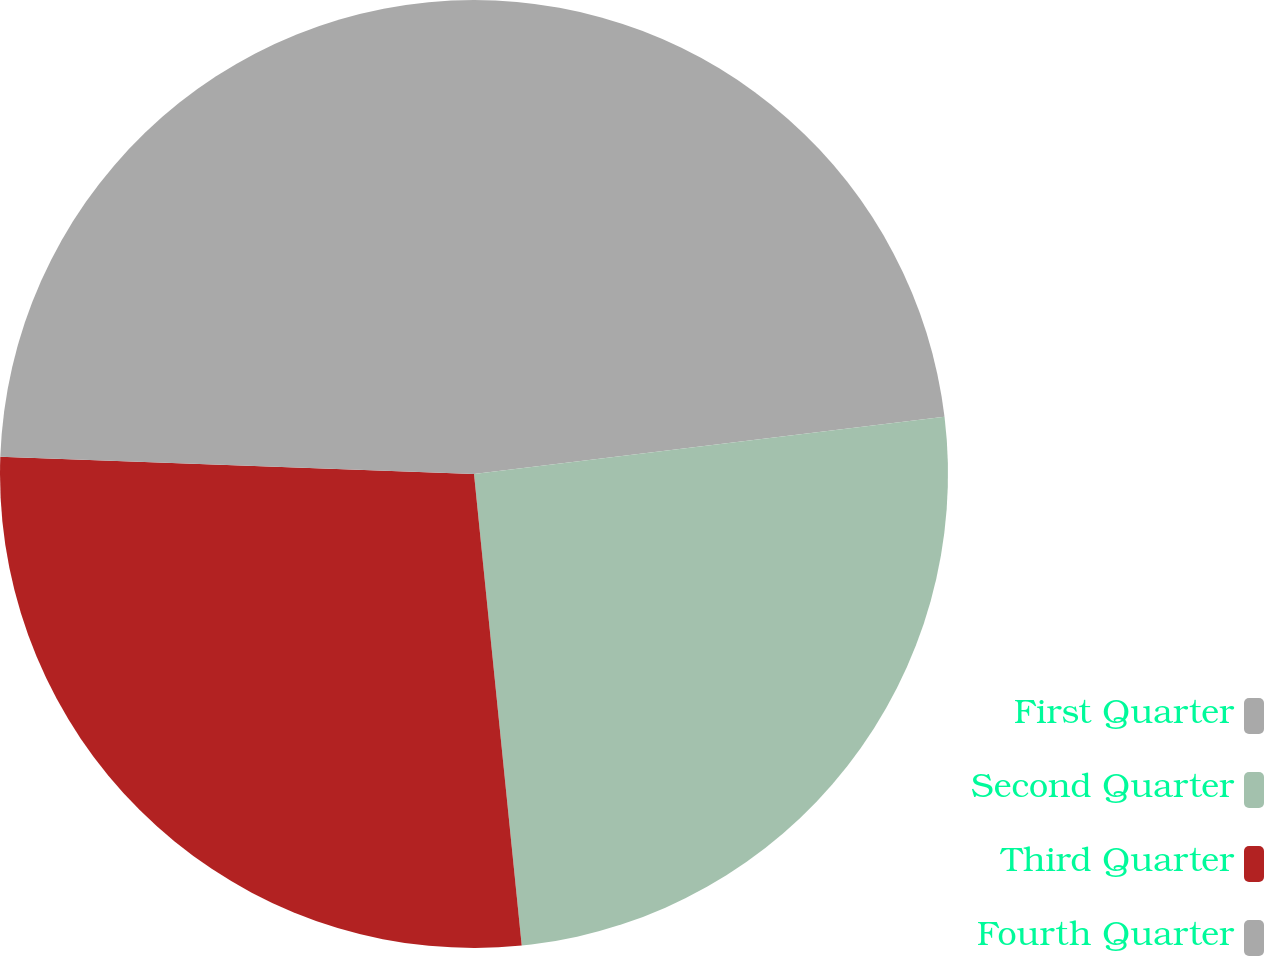Convert chart. <chart><loc_0><loc_0><loc_500><loc_500><pie_chart><fcel>First Quarter<fcel>Second Quarter<fcel>Third Quarter<fcel>Fourth Quarter<nl><fcel>23.07%<fcel>25.32%<fcel>27.18%<fcel>24.42%<nl></chart> 